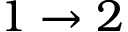<formula> <loc_0><loc_0><loc_500><loc_500>1 \to 2</formula> 